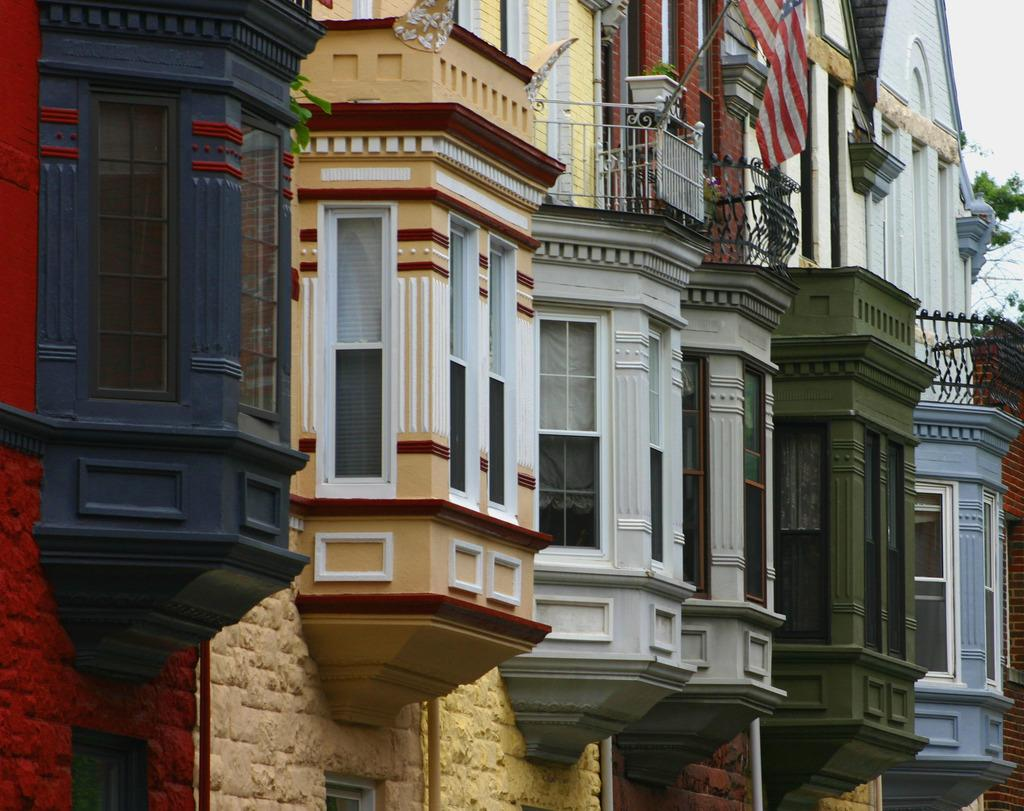What type of structures are in the foreground of the image? There are colorful buildings in the foreground of the image. What feature do the buildings have? The buildings have glass windows. Are there any additional architectural elements on top of the buildings? Yes, there are railings on top of the buildings. What can be seen flying on top of the buildings? There is a flag on top of the buildings. What type of cable can be seen connecting the buildings in the image? There is no cable connecting the buildings in the image. What is the grip of the middle building in the image? The image does not show any information about the grip of the middle building, as it focuses on the buildings' appearance and features. 